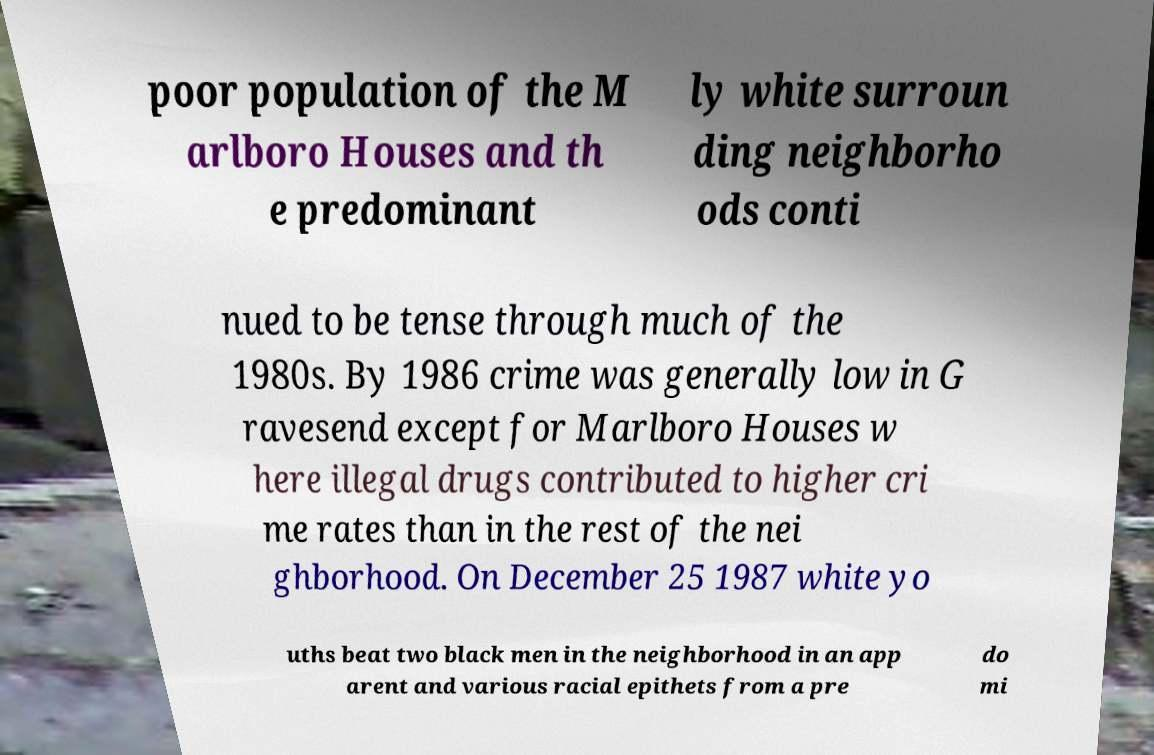What messages or text are displayed in this image? I need them in a readable, typed format. poor population of the M arlboro Houses and th e predominant ly white surroun ding neighborho ods conti nued to be tense through much of the 1980s. By 1986 crime was generally low in G ravesend except for Marlboro Houses w here illegal drugs contributed to higher cri me rates than in the rest of the nei ghborhood. On December 25 1987 white yo uths beat two black men in the neighborhood in an app arent and various racial epithets from a pre do mi 